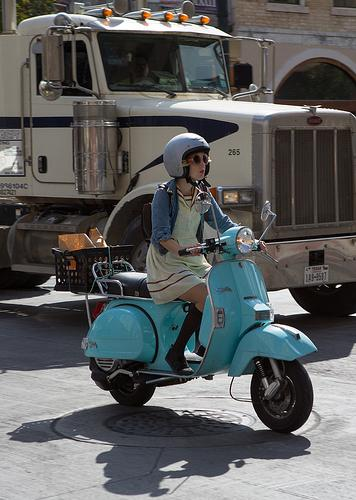Can you identify any unique features on the semi-truck in the image?  The semi-truck has numbers on its side. What are the round objects on the road that are large and small in size respectively? A large manhole cover and a shadow from the girl on the scooter. Can you list some notable objects on the scooter, and their colors? Black basket, gray helmet, sunglasses, headlight, mirror, and front tire. What is the large vehicle near the girl on the scooter and where is it located in the image? A huge semi-truck is driving next to the girl on the scooter. Briefly describe the attire of the girl riding the scooter. The girl is wearing a dress and black socks. What is the primary mode of transportation depicted in the image? A blue scooter with a girl riding it. What type of surface is the girl on the scooter driving on? A road made of concrete. Please describe any items in the basket on the scooter. There are brown paper bags inside the black basket. Describe any prominent object present in the background of the image. A green tree and a building are in the background. Mention any safety gear the girl on the scooter is wearing and its color. The girl is wearing a gray helmet and sunglasses. 